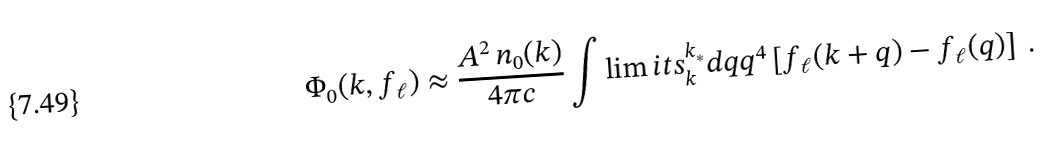Convert formula to latex. <formula><loc_0><loc_0><loc_500><loc_500>\Phi _ { 0 } ( k , f _ { \ell } ) \approx \frac { A ^ { 2 } \, n _ { 0 } ( k ) } { 4 \pi c } \int \lim i t s _ { k } ^ { k _ { * } } d q q ^ { 4 } \left [ f _ { \ell } ( k + q ) - f _ { \ell } ( q ) \right ] \ .</formula> 